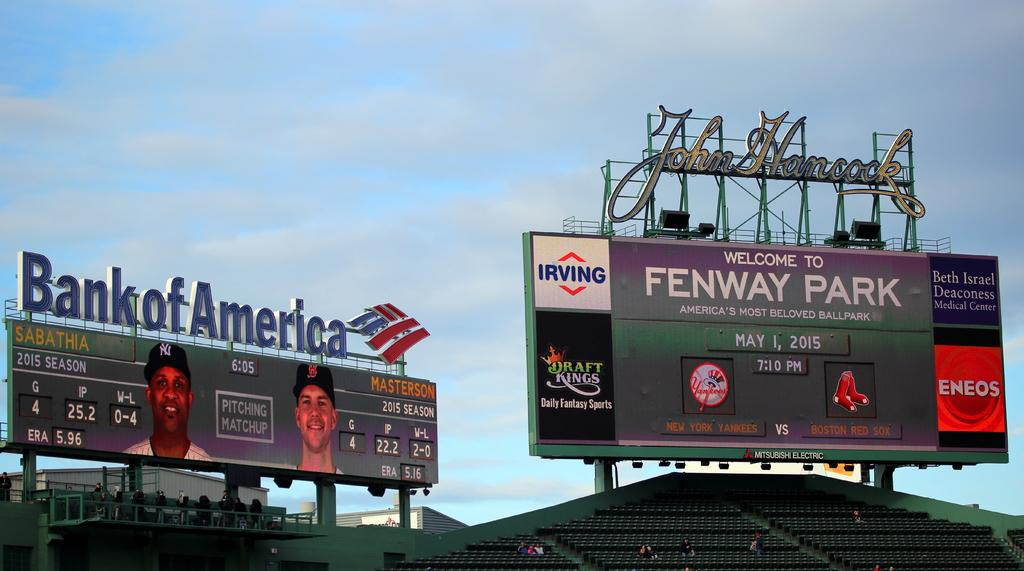<image>
Render a clear and concise summary of the photo. A large billboard welcomes people to Fenway Park on May 1, 2015. 